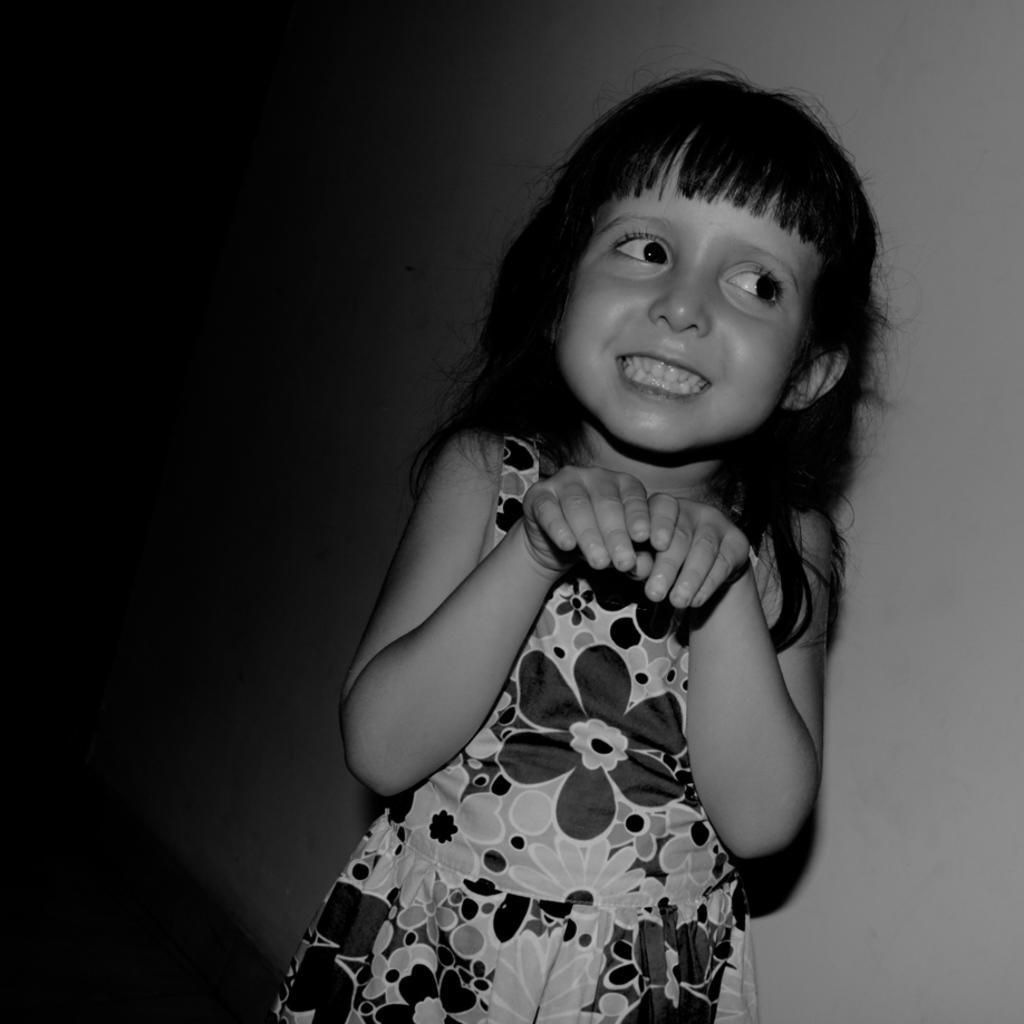Can you describe this image briefly? This is a black and white image. In this image there is a girl smiling. In the back there is a wall. 